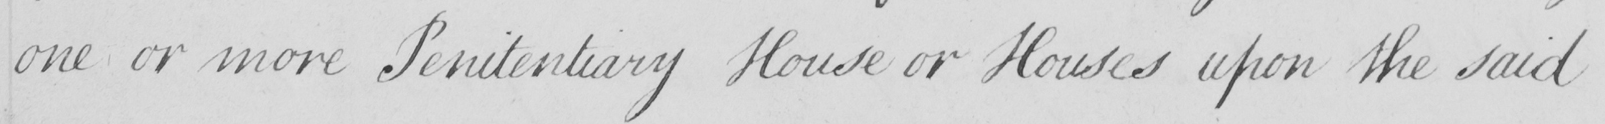Please provide the text content of this handwritten line. one or more Penitentiary House or Houses upon the said 